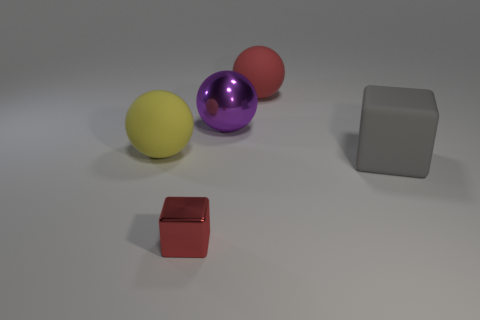Is there a color theme represented in the objects shown? The objects seem to adhere to primary and secondary colors. There's a red block, a yellow ball, and a purple ball, which is a secondary color made by combining red and blue. The metallic block doesn't fall under this theme as it's grey, a neutral color. 